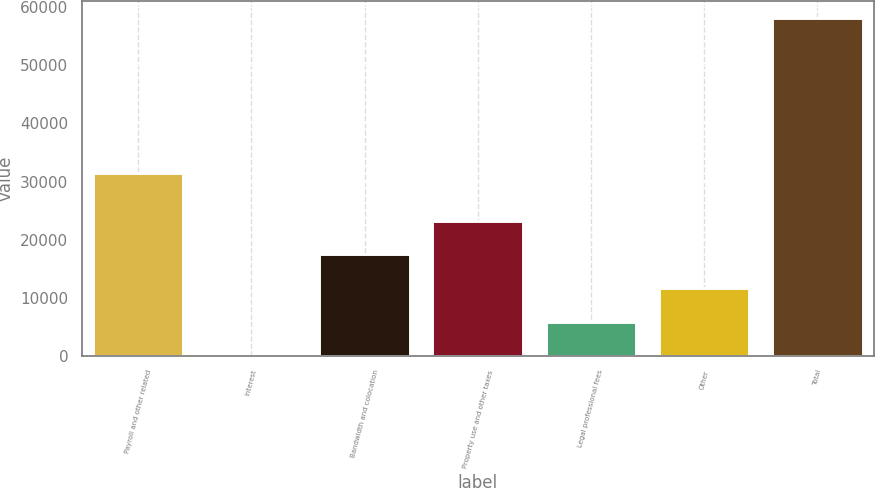Convert chart. <chart><loc_0><loc_0><loc_500><loc_500><bar_chart><fcel>Payroll and other related<fcel>Interest<fcel>Bandwidth and colocation<fcel>Property use and other taxes<fcel>Legal professional fees<fcel>Other<fcel>Total<nl><fcel>31429<fcel>83<fcel>17483<fcel>23283<fcel>5883<fcel>11683<fcel>58083<nl></chart> 